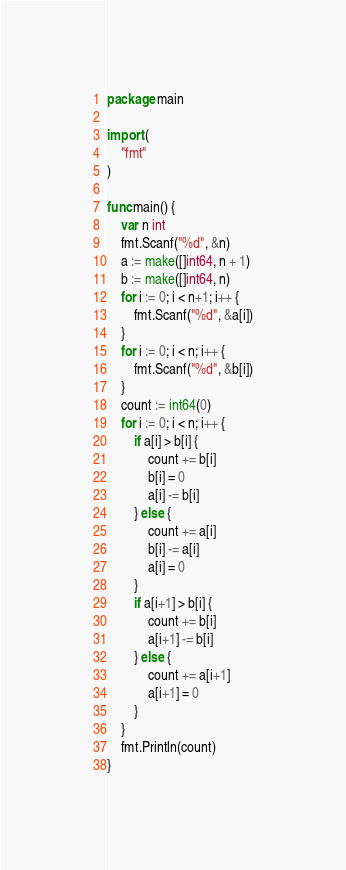<code> <loc_0><loc_0><loc_500><loc_500><_Go_>package main

import (
	"fmt"
)

func main() {
	var n int
	fmt.Scanf("%d", &n)
	a := make([]int64, n + 1)
	b := make([]int64, n)
	for i := 0; i < n+1; i++ {
		fmt.Scanf("%d", &a[i])
	}
	for i := 0; i < n; i++ {
		fmt.Scanf("%d", &b[i])
	}
	count := int64(0)
	for i := 0; i < n; i++ {
		if a[i] > b[i] {
			count += b[i]
			b[i] = 0
			a[i] -= b[i]
		} else {
			count += a[i]
			b[i] -= a[i]
			a[i] = 0
		}
		if a[i+1] > b[i] {
			count += b[i]
			a[i+1] -= b[i]
		} else {
			count += a[i+1]
			a[i+1] = 0
		}
	}
	fmt.Println(count)
}
</code> 